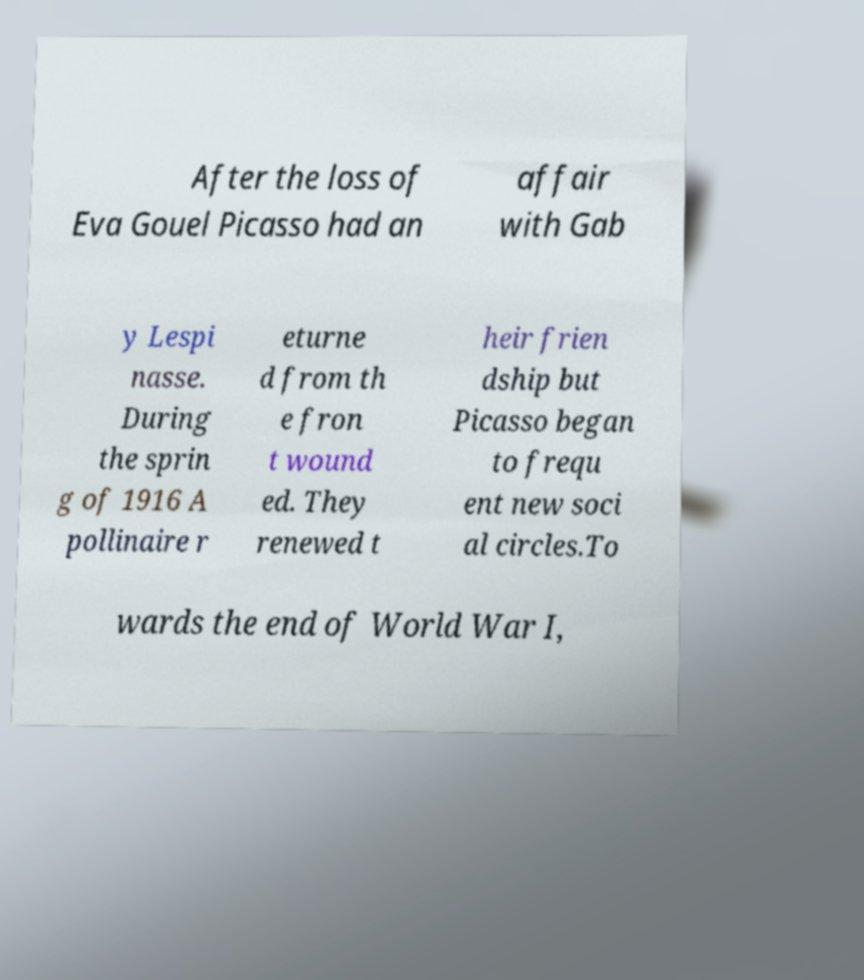Could you assist in decoding the text presented in this image and type it out clearly? After the loss of Eva Gouel Picasso had an affair with Gab y Lespi nasse. During the sprin g of 1916 A pollinaire r eturne d from th e fron t wound ed. They renewed t heir frien dship but Picasso began to frequ ent new soci al circles.To wards the end of World War I, 